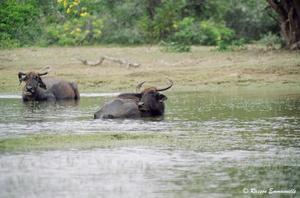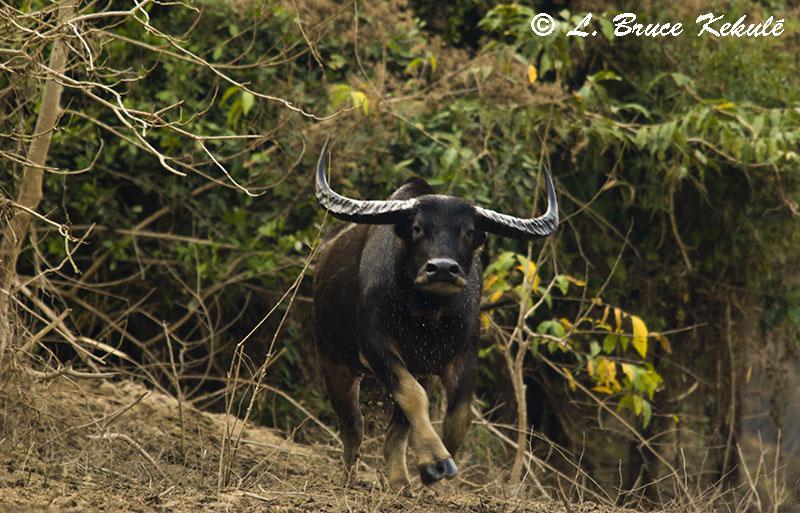The first image is the image on the left, the second image is the image on the right. Analyze the images presented: Is the assertion "The right image contains exactly one water buffalo." valid? Answer yes or no. Yes. The first image is the image on the left, the second image is the image on the right. Given the left and right images, does the statement "At least 2 cows are standing in the water." hold true? Answer yes or no. Yes. 